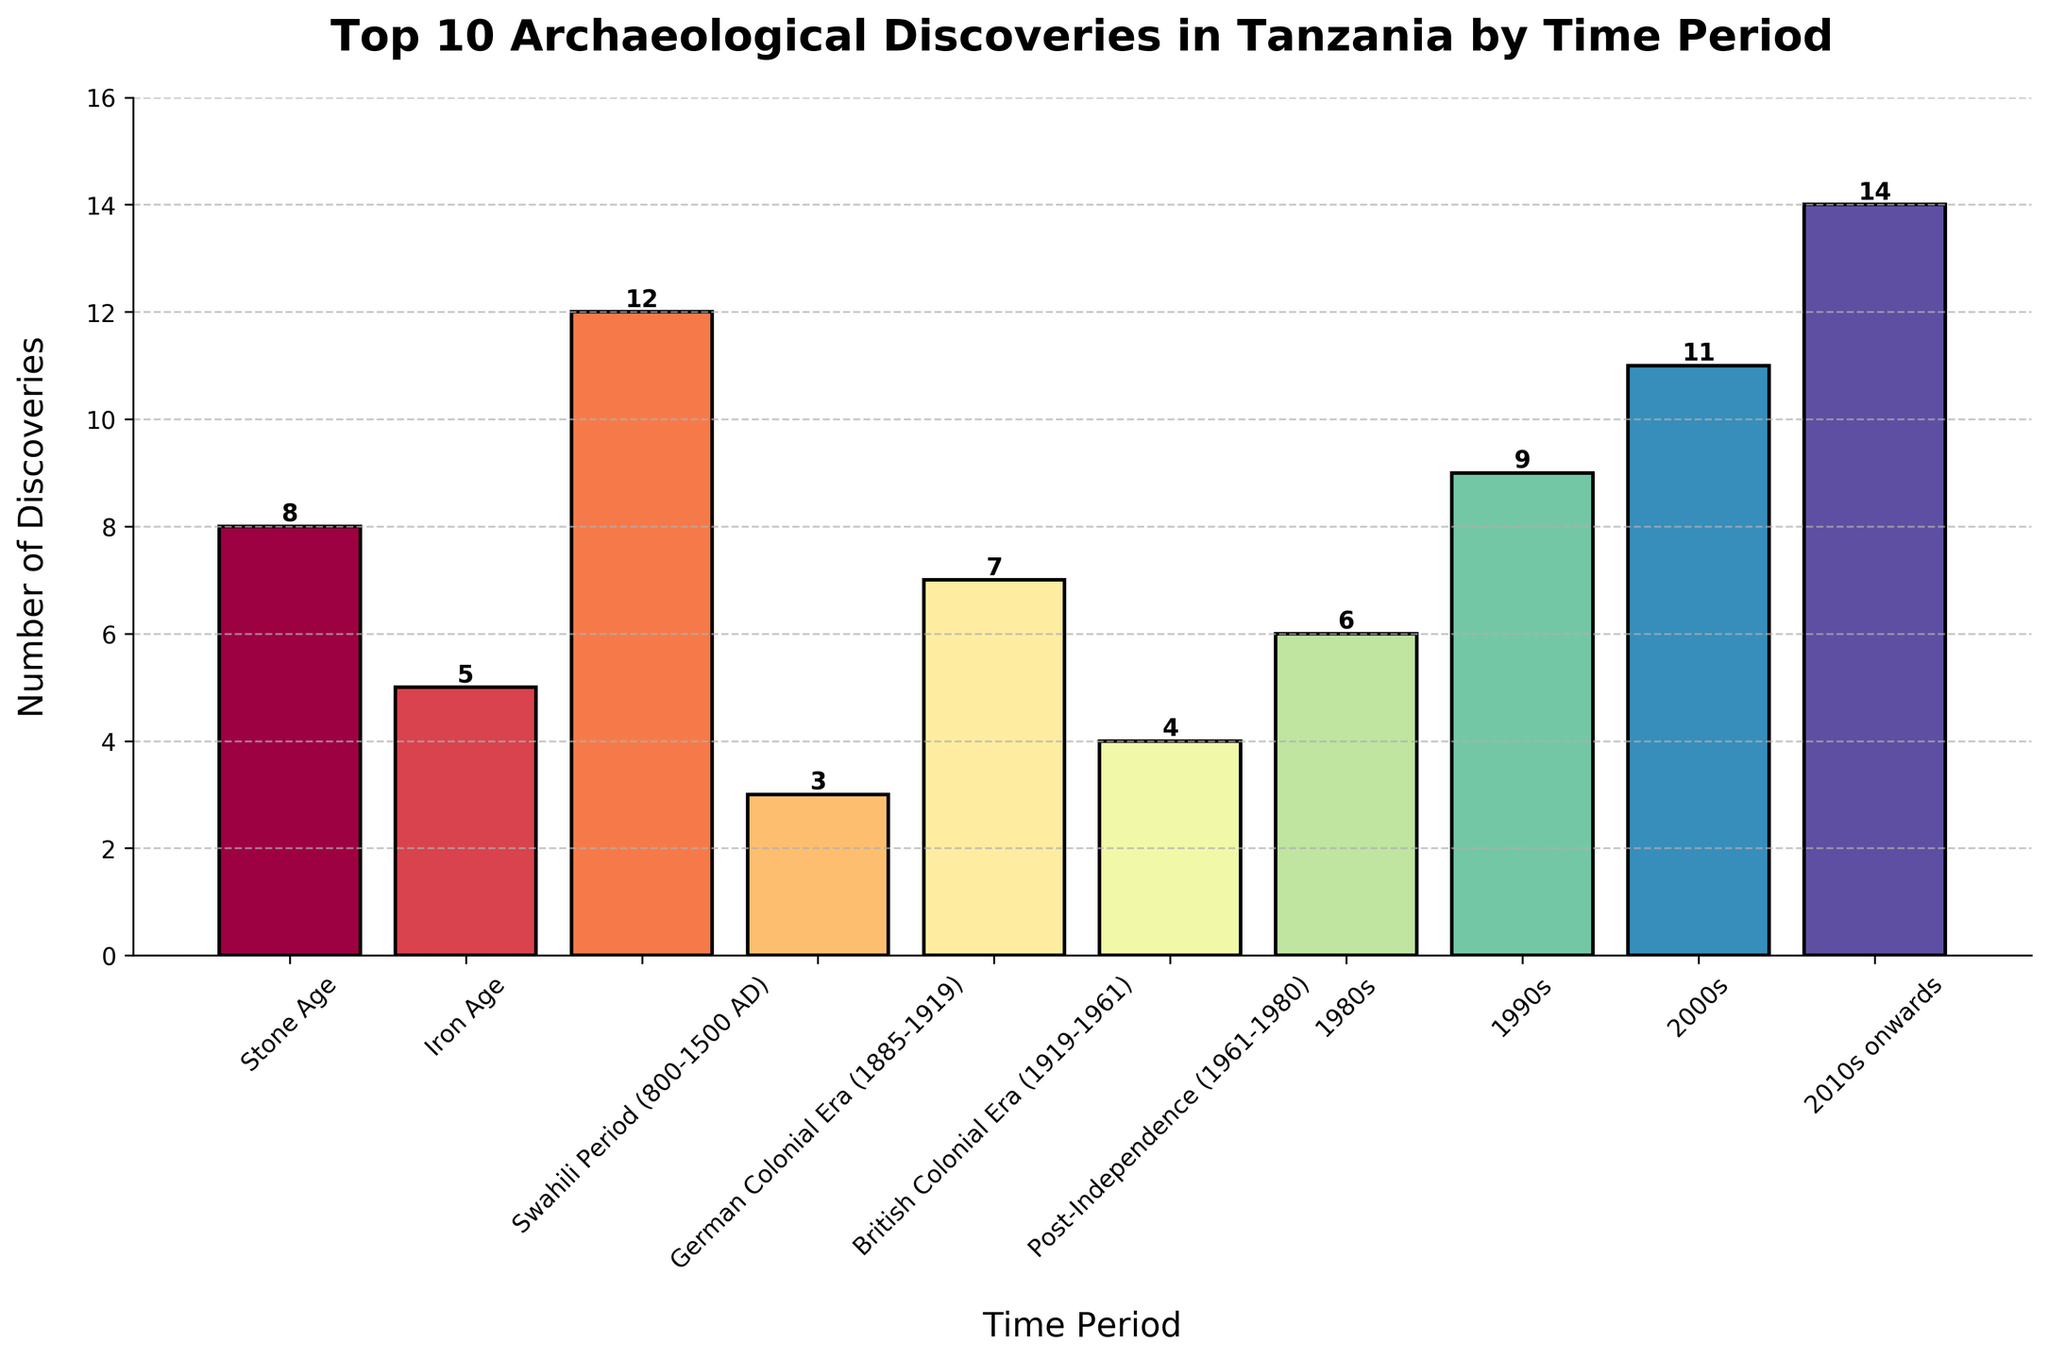Which time period had the highest number of archaeological discoveries? Looking at the bar chart, the time period with the tallest bar represents the highest number of discoveries. This is the "2010s onwards" period.
Answer: 2010s onwards During which time periods did the number of discoveries exceed 10? Observing the heights of the bars, the "Swahili Period (800-1500 AD)" with 12 discoveries, the "2000s" with 11 discoveries, and the "2010s onwards" with 14 discoveries all exceeded 10.
Answer: Swahili Period (800-1500 AD), 2000s, 2010s onwards How many more discoveries were there in the 2010s onwards compared to the Iron Age? The number of discoveries in the "2010s onwards" is 14, and in the "Iron Age," it is 5. So, 14 - 5 = 9.
Answer: 9 What is the combined number of discoveries from the Stone Age and British Colonial Era? Summing the discoveries from both periods: Stone Age (8) + British Colonial Era (7) = 15.
Answer: 15 Which time period had the fewest archaeological discoveries? The shortest bar represents the fewest discoveries, which is the "German Colonial Era" with 3 discoveries.
Answer: German Colonial Era Were there more discoveries in the 1990s or the 2000s? Comparing the heights of the bars, the 1990s had 9 discoveries and the 2000s had 11 discoveries.
Answer: 2000s What is the average number of discoveries across all time periods? Adding up all the discoveries and dividing by the number of periods: (8 + 5 + 12 + 3 + 7 + 4 + 6 + 9 + 11 + 14) = 79. There are 10 periods, so 79 / 10 = 7.9.
Answer: 7.9 Which two consecutive periods had the largest increase in the number of discoveries? Calculate the differences between consecutive periods: 
Iron Age (5) - Stone Age (8) = -3,
Swahili Period (12) - Iron Age (5) = 7,
German Colonial Era (3) - Swahili Period (12) = -9,
British Colonial Era (7) - German Colonial Era (3) = 4,
Post-Independence (4) - British Colonial Era (7) = -3,
1980s (6) - Post-Independence (4) = 2,
1990s (9) - 1980s (6) = 3,
2000s (11) - 1990s (9) = 2,
2010s onwards (14) - 2000s (11) = 3.
The largest increase of 7 is from the Iron Age to the Swahili Period (800-1500 AD).
Answer: Iron Age to Swahili Period (800-1500 AD) What is the total number of discoveries made before Tanzania's independence in 1961? Sum the discoveries from the periods before independence: Stone Age (8), Iron Age (5), Swahili Period (12), German Colonial Era (3), British Colonial Era (7) = 8 + 5 + 12 + 3 + 7 = 35.
Answer: 35 